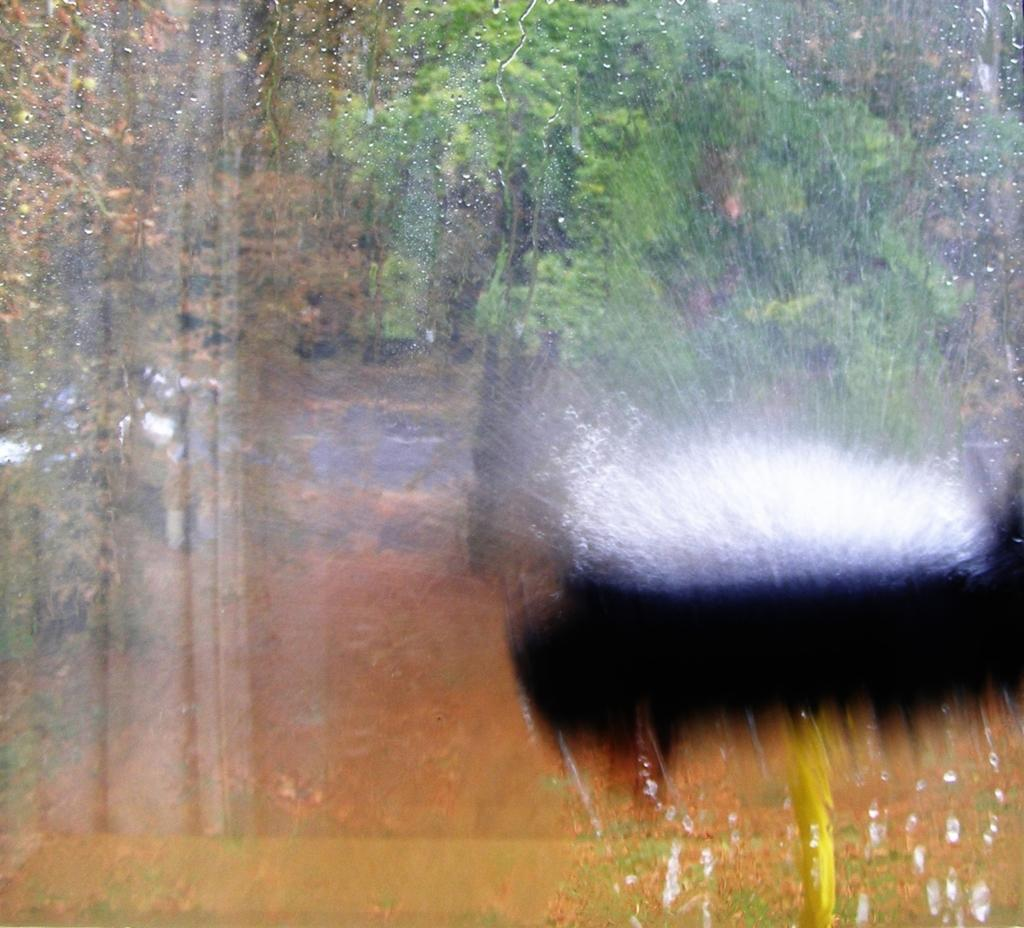What can be observed about the quality of the image? The image is blurry. What type of natural scenery can be seen in the background of the image? There are trees in the background of the image. How many eyes can be seen on the bushes in the image? There are no bushes or eyes present in the image; it only features trees in the background. 